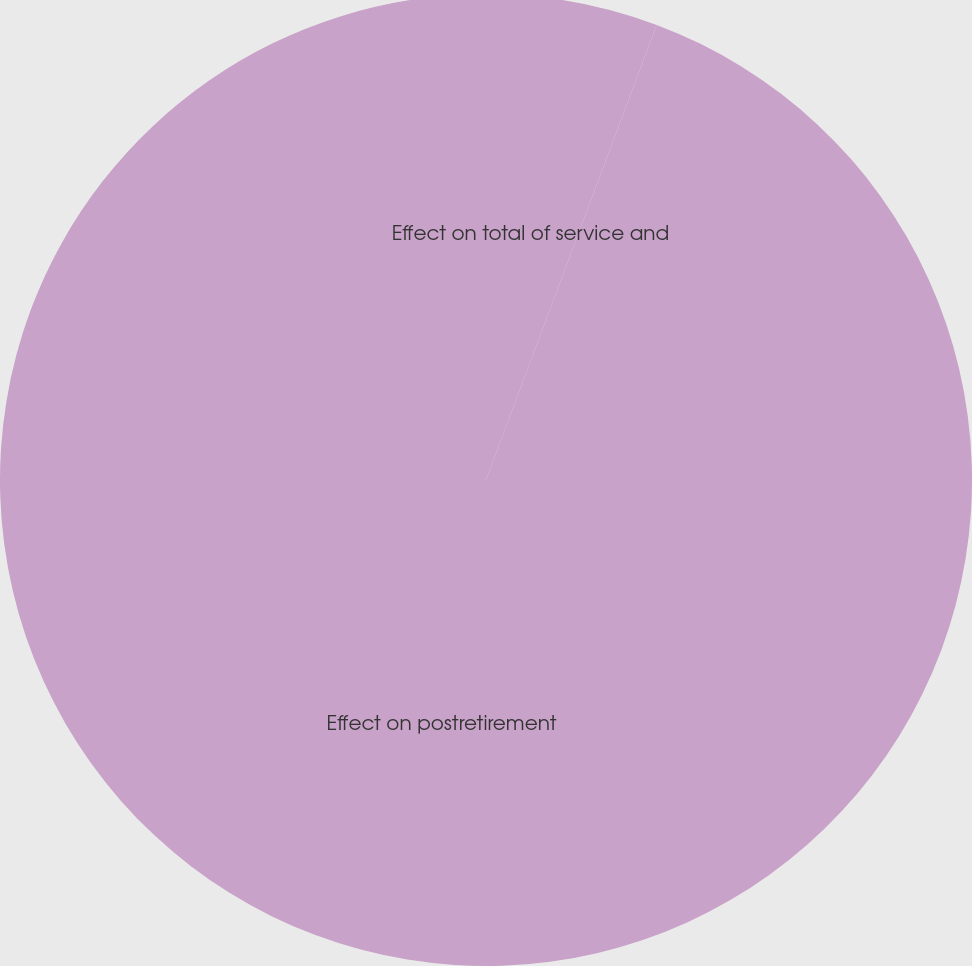<chart> <loc_0><loc_0><loc_500><loc_500><pie_chart><fcel>Effect on total of service and<fcel>Effect on postretirement<nl><fcel>5.71%<fcel>94.29%<nl></chart> 